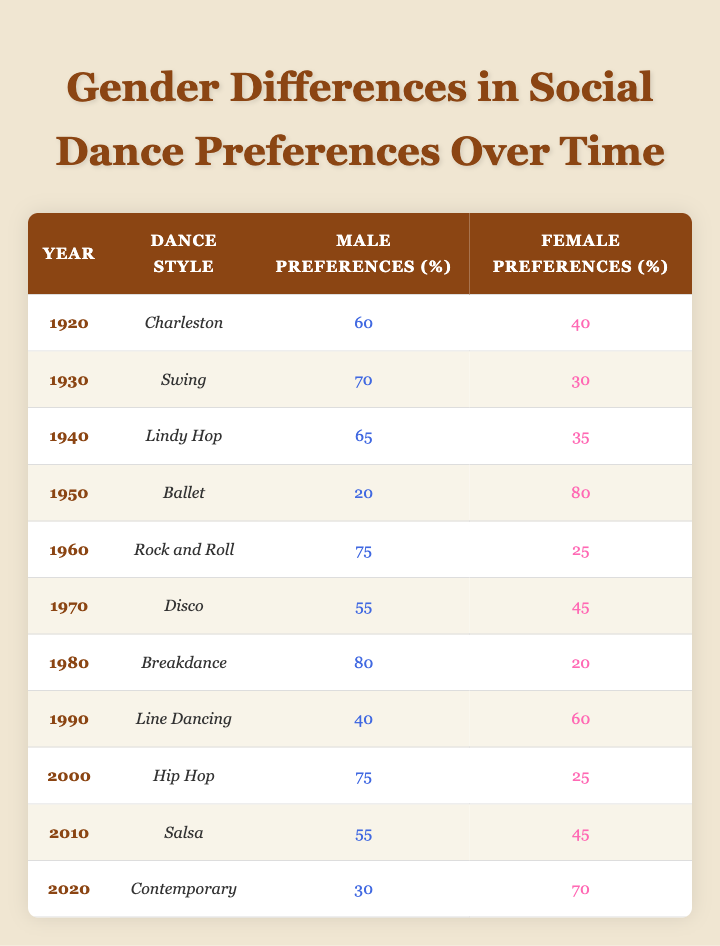What percentage of male preferences for the Charleston dance style is recorded in 1920? In 1920, the table states that male preferences for the Charleston dance style were 60%.
Answer: 60% What is the dance style with the highest male preference and what was the percentage? Looking through the table, the dance style with the highest male preference is Breakdance in 1980, with a percentage of 80%.
Answer: Breakdance, 80% How many more percentage points did female preferences for Ballet in 1950 outnumber male preferences? In 1950, female preferences for Ballet were 80% while male preferences were 20%. The difference is 80 - 20 = 60 percentage points.
Answer: 60 True or False: In 2010, the male preference for Salsa was higher than 50%. The table shows that male preferences for Salsa in 2010 were 55%, which is greater than 50%, thus the statement is true.
Answer: True What is the average percentage of female preferences from 1920 to 2020? First, we sum female preferences from each year: 40 + 30 + 35 + 80 + 25 + 45 + 20 + 60 + 25 + 45 + 70 = 505. Then, divide by the number of years (11): 505 / 11 ≈ 45.91%.
Answer: 45.91% Which dance style showed an increase in male preferences from 1940 to 1960? In 1940, male preferences for Lindy Hop were 65%, and in 1960, male preferences for Rock and Roll were 75%. This indicates an increase of 10 percentage points from 1940 to 1960.
Answer: Rock and Roll Did female preferences for Contemporary in 2020 exceed 60%? The table indicates that female preferences for Contemporary were 70% in 2020, which does exceed 60%. Thus, the answer is yes.
Answer: Yes What is the difference in male preferences between 1980's Breakdance and 1990's Line Dancing? In 1980, male preferences for Breakdance were 80%, while in 1990, they were 40% for Line Dancing. The difference is 80 - 40 = 40 percentage points.
Answer: 40 In which decade were female preferences for dance styles overall higher, the 1950s or the 2000s? In the 1950s, the female preference for Ballet was 80%. In the 2000s, preferences were 25% for Hip Hop (2000), and 45% for Salsa (2010), contributing to a total of 70% for the decade. Thus, the 1950s had higher female preferences overall.
Answer: 1950s 